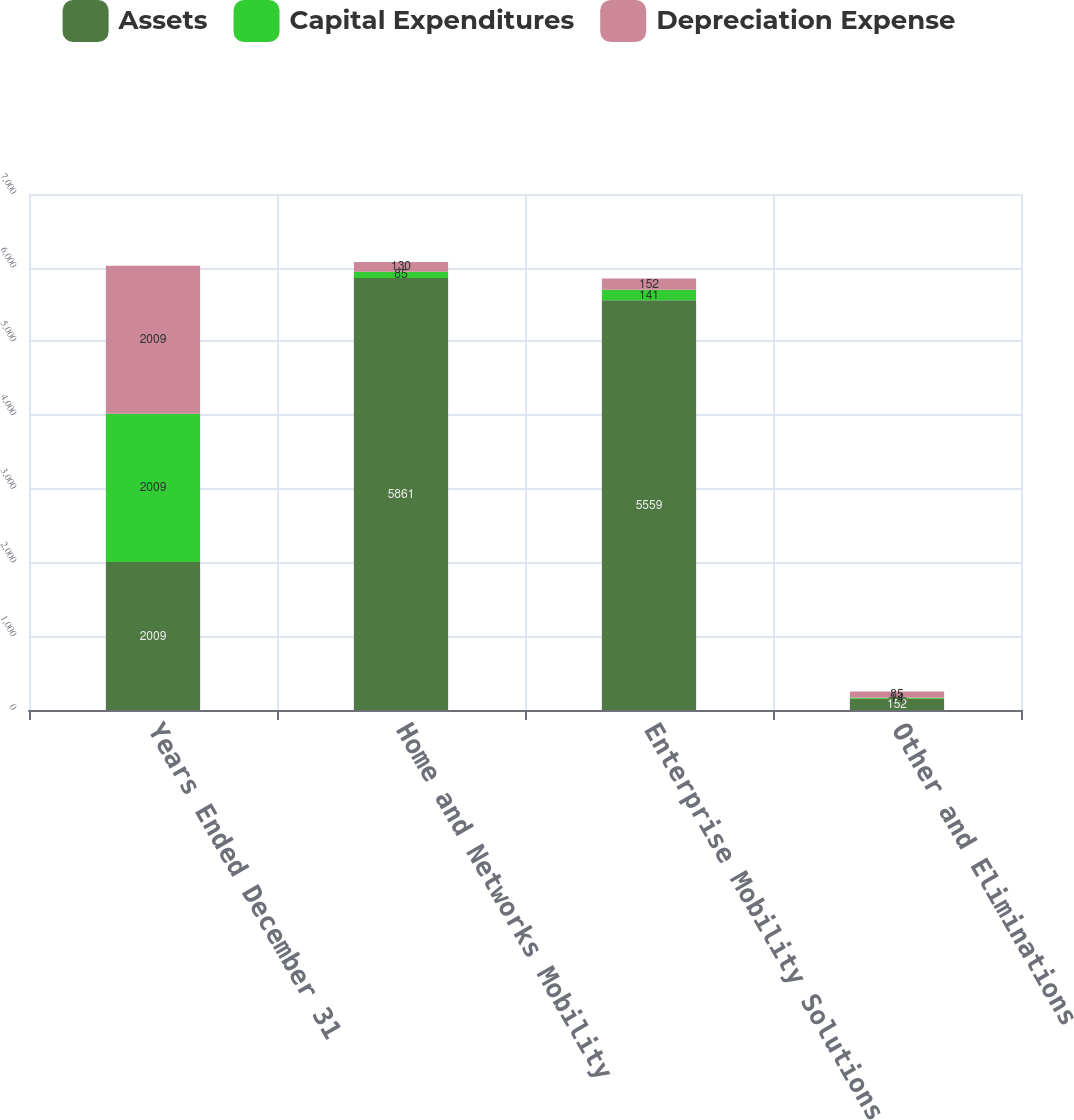<chart> <loc_0><loc_0><loc_500><loc_500><stacked_bar_chart><ecel><fcel>Years Ended December 31<fcel>Home and Networks Mobility<fcel>Enterprise Mobility Solutions<fcel>Other and Eliminations<nl><fcel>Assets<fcel>2009<fcel>5861<fcel>5559<fcel>152<nl><fcel>Capital Expenditures<fcel>2009<fcel>85<fcel>141<fcel>14<nl><fcel>Depreciation Expense<fcel>2009<fcel>130<fcel>152<fcel>85<nl></chart> 